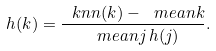Convert formula to latex. <formula><loc_0><loc_0><loc_500><loc_500>h ( k ) = \frac { \ k n n ( k ) - \ m e a n { k } } { \ m e a n { j \, h ( j ) } } .</formula> 